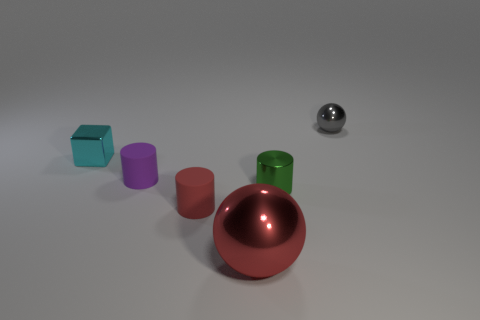What materials do the objects appear to be made of? The objects exhibit different materials by their texture and sheen. The cyan and purple items appear matte and possibly made of plastic, while the green, red, and silver objects have reflective surfaces, indicating they could be metallic. 